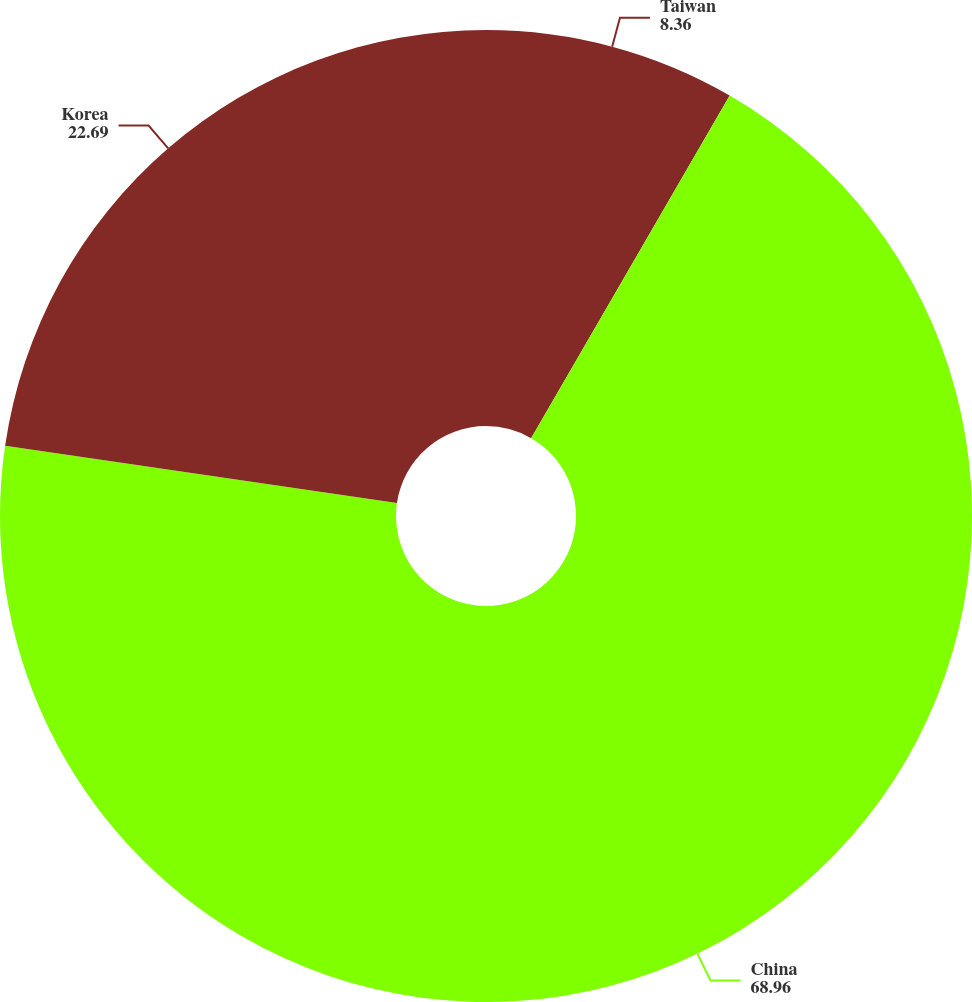Convert chart to OTSL. <chart><loc_0><loc_0><loc_500><loc_500><pie_chart><fcel>Taiwan<fcel>China<fcel>Korea<nl><fcel>8.36%<fcel>68.96%<fcel>22.69%<nl></chart> 